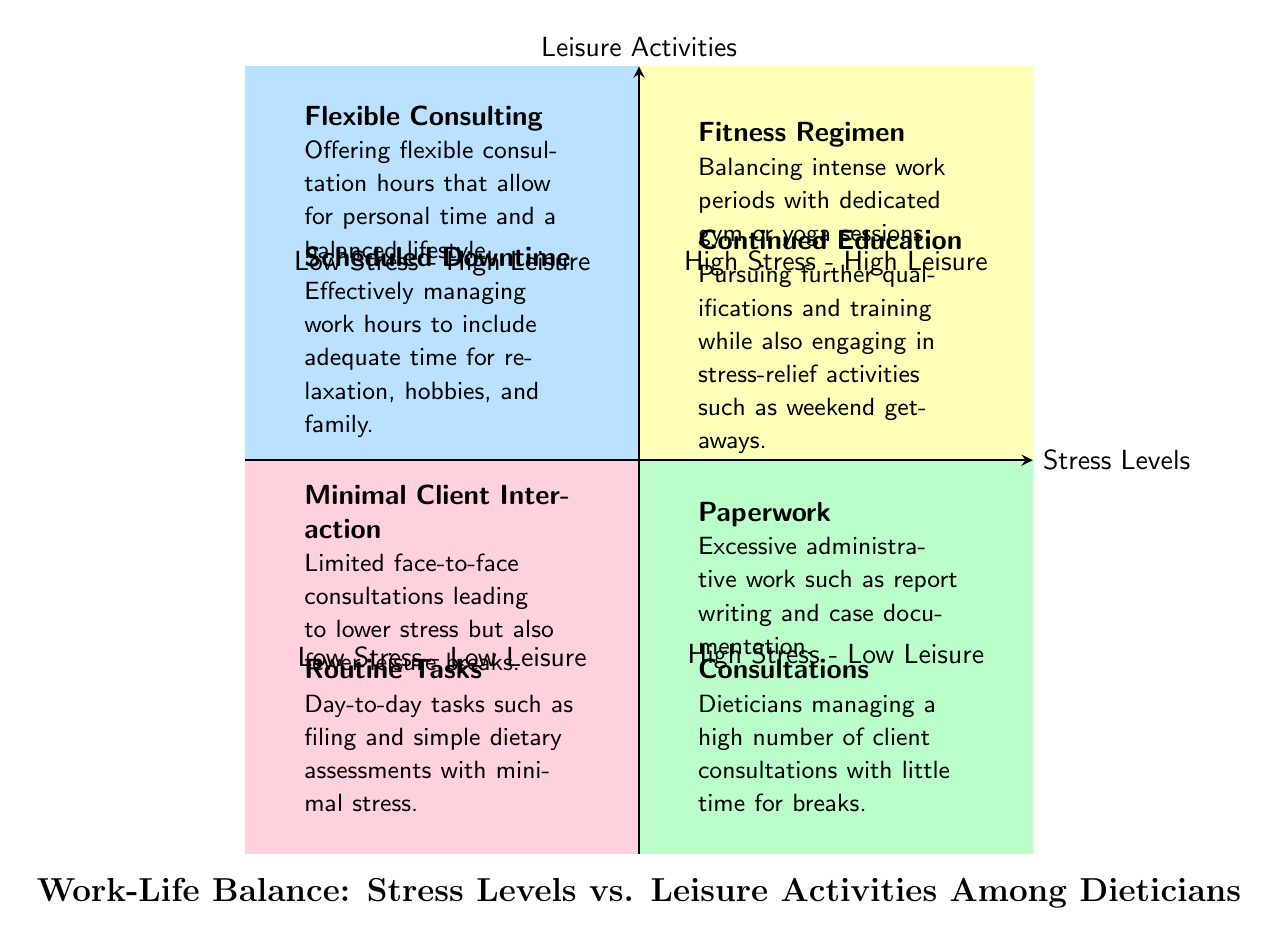What elements are in the "High Stress - Low Leisure" quadrant? The "High Stress - Low Leisure" quadrant includes "Consultations" and "Paperwork", which are activities associated with high stress and minimal leisure time.
Answer: Consultations, Paperwork How many elements are in the "Low Stress - High Leisure" quadrant? "Low Stress - High Leisure" quadrant contains two elements: "Scheduled Downtime" and "Flexible Consulting".
Answer: 2 What type of activities are represented in the "High Stress - High Leisure" quadrant? This quadrant includes "Continued Education" and "Fitness Regimen", highlighting a balance between stressful work tasks and engaging in leisure activities.
Answer: Continued Education, Fitness Regimen Which quadrant contains activities with minimal stress but also low leisure? The quadrant that includes activities with minimal stress and low leisure is "Low Stress - Low Leisure", featuring "Routine Tasks" and "Minimal Client Interaction".
Answer: Low Stress - Low Leisure What is a key characteristic of the "Flexible Consulting" element? "Flexible Consulting" allows dieticians to offer adaptable hours, which promotes personal time and contributes to a balanced lifestyle.
Answer: Offers flexible consultation hours What is the primary focus of the "Continued Education" element? "Continued Education" focuses on professional development while also incorporating leisure activities, like weekend retreats, to alleviate stress.
Answer: Pursuing further qualifications and training How do "Routine Tasks" relate to overall stress levels? "Routine Tasks" are associated with low stress levels due to their simplicity and minimal client interactions, suggesting a comfortable work environment.
Answer: Minimal stress Which quadrant has the highest combination of both leisure activities and stress levels? The quadrant with the highest combination of leisure activities and stress is "High Stress - High Leisure", indicating that even high-stress environments can coexist with leisure pursuits.
Answer: High Stress - High Leisure 